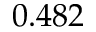Convert formula to latex. <formula><loc_0><loc_0><loc_500><loc_500>0 . 4 8 2</formula> 